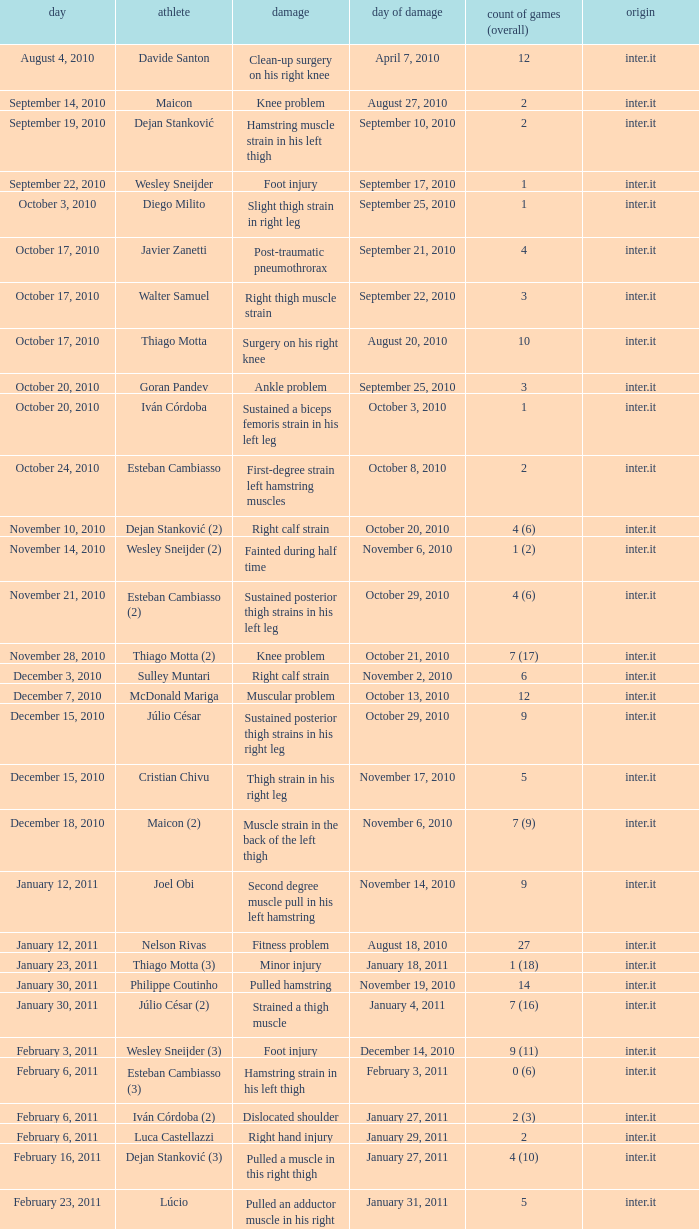How many times was the date october 3, 2010? 1.0. 